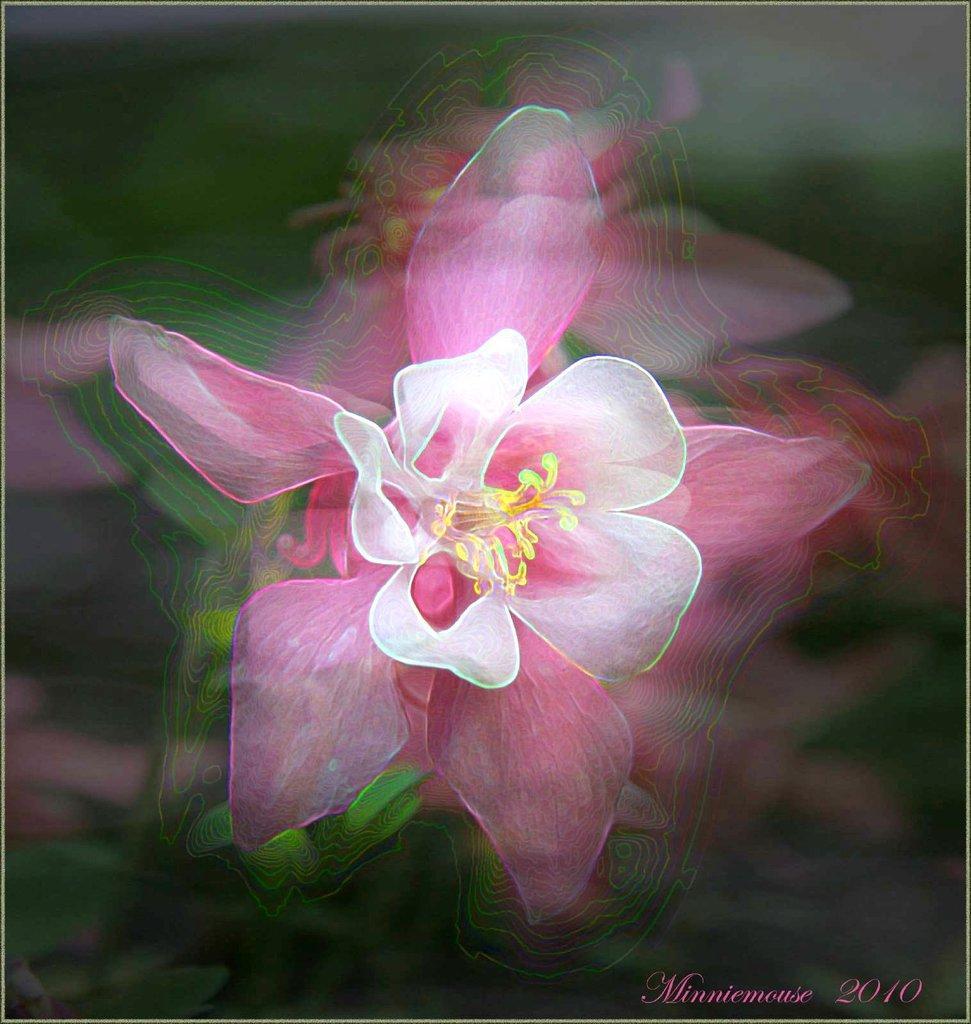Could you give a brief overview of what you see in this image? In this picture we can see a flower. In the background of the image it is blurry. In the bottom right side of the image we can see text and year. 